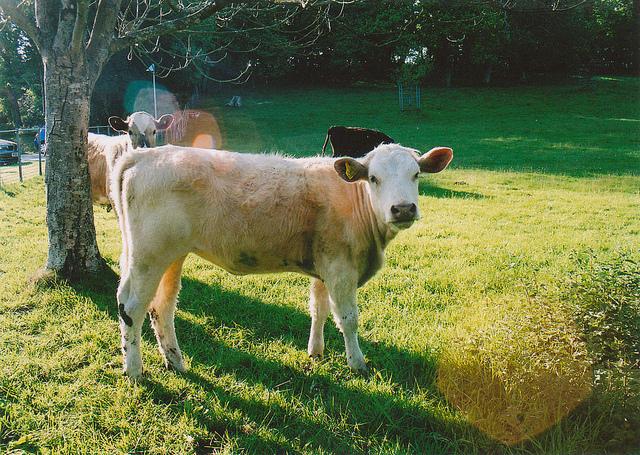Does the grass need to be cut?
Be succinct. No. How many young cows are there?
Short answer required. 3. What color is the calf?
Give a very brief answer. Brown. What color are the bull's shins?
Keep it brief. White. Is this a young cow?
Give a very brief answer. Yes. 